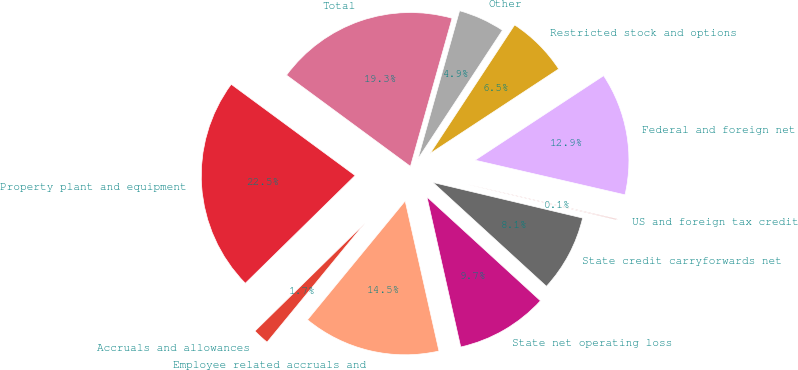<chart> <loc_0><loc_0><loc_500><loc_500><pie_chart><fcel>Accruals and allowances<fcel>Employee related accruals and<fcel>State net operating loss<fcel>State credit carryforwards net<fcel>US and foreign tax credit<fcel>Federal and foreign net<fcel>Restricted stock and options<fcel>Other<fcel>Total<fcel>Property plant and equipment<nl><fcel>1.7%<fcel>14.47%<fcel>9.68%<fcel>8.08%<fcel>0.1%<fcel>12.87%<fcel>6.49%<fcel>4.89%<fcel>19.26%<fcel>22.45%<nl></chart> 